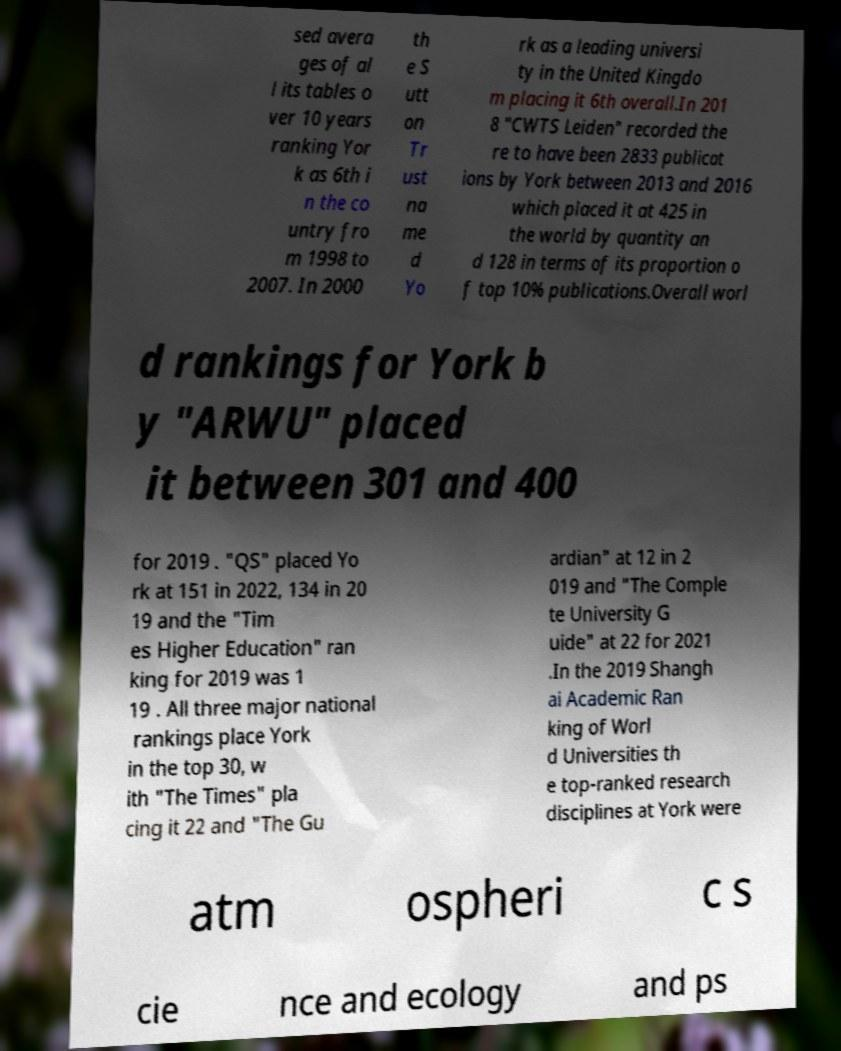Please read and relay the text visible in this image. What does it say? sed avera ges of al l its tables o ver 10 years ranking Yor k as 6th i n the co untry fro m 1998 to 2007. In 2000 th e S utt on Tr ust na me d Yo rk as a leading universi ty in the United Kingdo m placing it 6th overall.In 201 8 "CWTS Leiden" recorded the re to have been 2833 publicat ions by York between 2013 and 2016 which placed it at 425 in the world by quantity an d 128 in terms of its proportion o f top 10% publications.Overall worl d rankings for York b y "ARWU" placed it between 301 and 400 for 2019 . "QS" placed Yo rk at 151 in 2022, 134 in 20 19 and the "Tim es Higher Education" ran king for 2019 was 1 19 . All three major national rankings place York in the top 30, w ith "The Times" pla cing it 22 and "The Gu ardian" at 12 in 2 019 and "The Comple te University G uide" at 22 for 2021 .In the 2019 Shangh ai Academic Ran king of Worl d Universities th e top-ranked research disciplines at York were atm ospheri c s cie nce and ecology and ps 